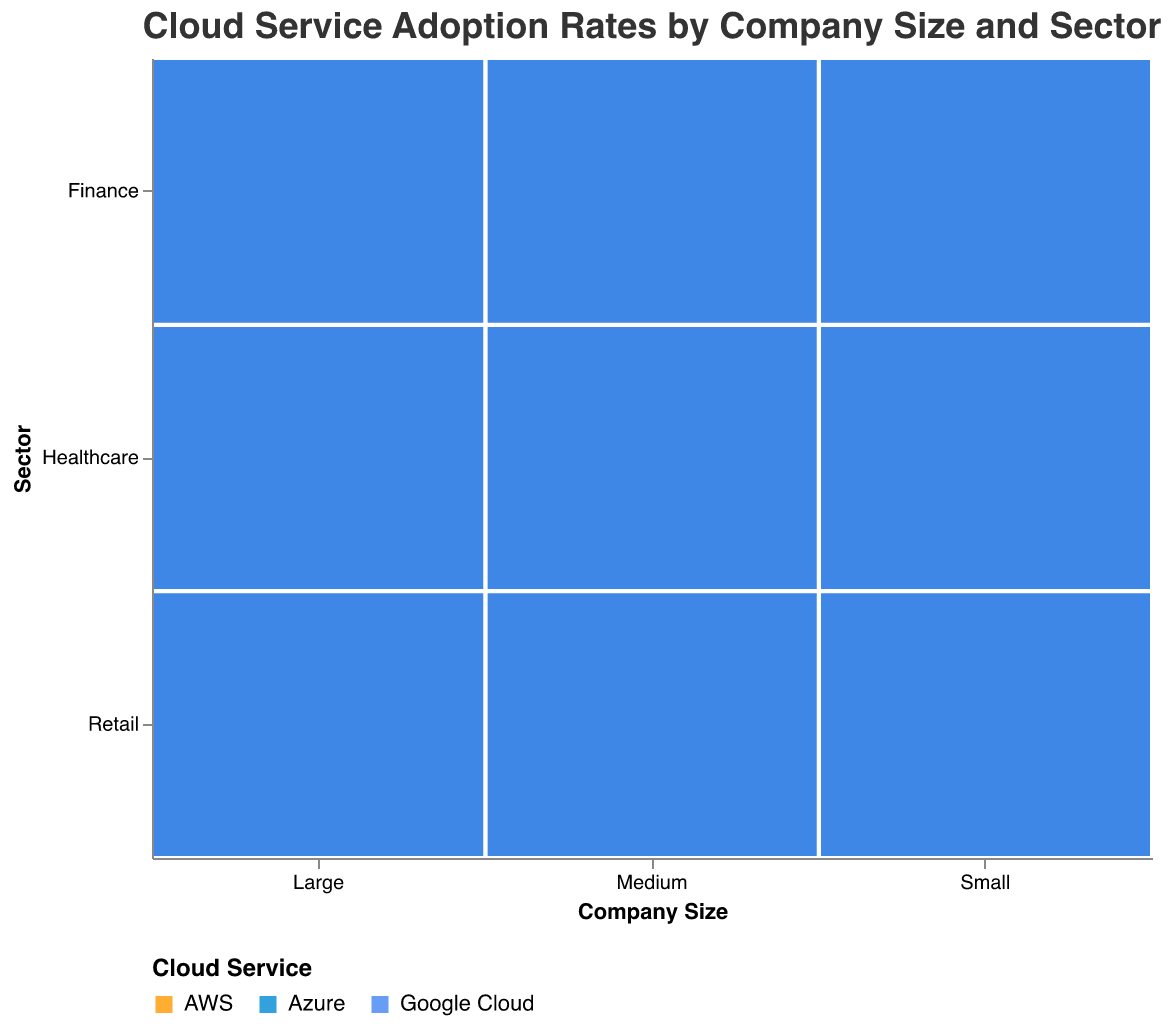What is the title of the plot? The title is typically displayed at the top of the plot, providing an overall summary of what the plot represents. In this case, the title is "Cloud Service Adoption Rates by Company Size and Sector."
Answer: Cloud Service Adoption Rates by Company Size and Sector What sectors are represented in the dataset? The sectors are presented on the y-axis, in this case, they are "Healthcare," "Finance," and "Retail."
Answer: Healthcare, Finance, Retail Which cloud service has the highest adoption rate in large retail companies? In the large retail sector, the plot shows that AWS has the largest rectangle, indicating the highest adoption rate.
Answer: AWS Compare the adoption rates of AWS and Azure in medium finance companies. Which is higher? Look at the medium finance companies section and compare the sizes of the AWS and Azure rectangles. The AWS rectangle is larger, indicating a higher adoption rate.
Answer: AWS What is the smallest adoption rate for Google Cloud among medium companies, and in which sector is it? By examining the size of the Google Cloud rectangles in the medium sector, the smallest one is in the finance sector, with an adoption rate of 25.
Answer: 25 in Finance Which sector has the most balanced adoption rates across all three cloud services for large companies? Balance can be visually assessed by looking for similarly sized rectangles. For large companies, the healthcare sector appears to have more balanced adoption rates across AWS, Azure, and Google Cloud compared to finance and retail.
Answer: Healthcare What is the overall trend in cloud service adoption rates as company size increases? As company size increases from small to medium to large, the rectangles generally become larger, indicating higher adoption rates. This is seen across all sectors and cloud services.
Answer: Increases Which cloud service is least popular in the small finance sector? The smallest rectangle in the small finance sector represents the least popular cloud service, which is Google Cloud with an adoption rate of 15.
Answer: Google Cloud If you were to recommend a cloud service to a medium healthcare company aiming for widespread adoption, which would it be and why? For medium healthcare companies, AWS has the largest rectangle, indicating the highest adoption rate of 50. This suggests that AWS is the most widely adopted cloud service in this context.
Answer: AWS What is the difference in AWS adoption rates between large and medium companies in the retail sector? AWS adoption rate in large retail companies is 80, while in medium retail companies, it is 60. The difference is 80 - 60.
Answer: 20 